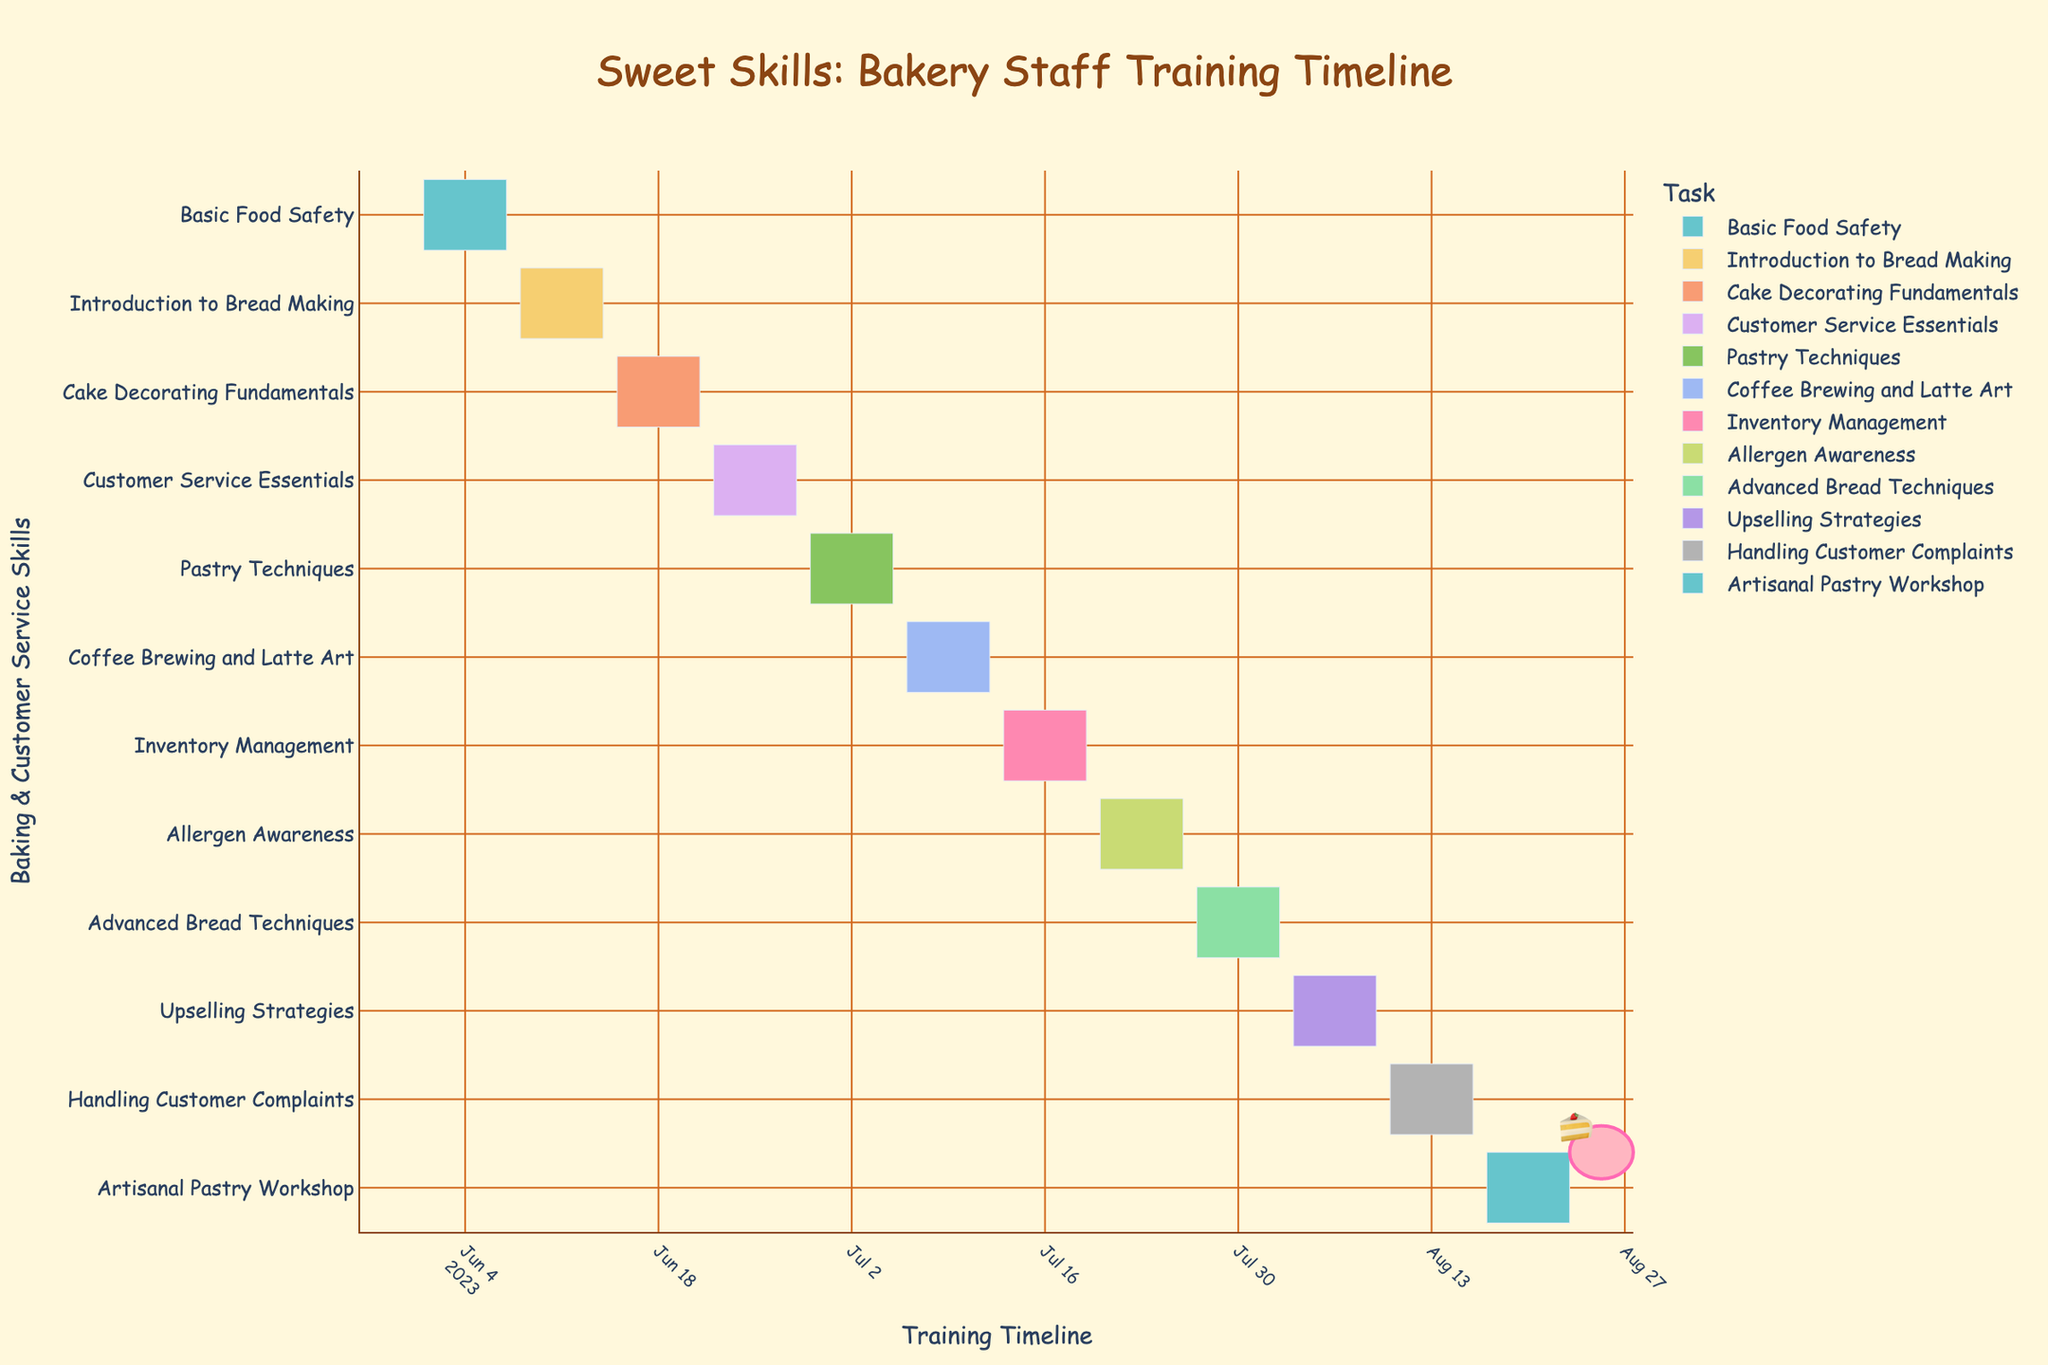Which task has the longest duration? By looking at the Gantt chart, notice the length of each bar. The longest bar corresponds to the “Basic Food Safety” task, which lasts for 7 days.
Answer: Basic Food Safety What dates cover the "Pastry Techniques" training? Find the "Pastry Techniques" bar on the Gantt chart and note its start and end dates. It starts on June 29, 2023, and ends on July 5, 2023.
Answer: June 29, 2023 to July 5, 2023 How many tasks are scheduled in July? Count the number of bars that fall within the July timeframe. There are tasks from July 1 to July 31. These tasks are: "Pastry Techniques", "Coffee Brewing and Latte Art", "Inventory Management", "Allergen Awareness", and "Advanced Bread Techniques".
Answer: 5 Which training takes place right after "Cake Decorating Fundamentals"? Find the end date of "Cake Decorating Fundamentals," which is June 21, 2023, and then identify the task that starts immediately after it. The next task is "Customer Service Essentials," which begins on June 22, 2023.
Answer: Customer Service Essentials Are there any tasks that last only one week (7 days)? Check the duration of each bar by subtracting the start date from the end date for each. Both "Basic Food Safety" (June 1-7) and "Introduction to Bread Making" (June 8-14) last for exactly 7 days.
Answer: Yes Which task runs from late July to early August? Look for a task bar that spans the transition from July to August. The "Advanced Bread Techniques" training runs from July 27, 2023, to August 2, 2023.
Answer: Advanced Bread Techniques What is the title of the Gantt chart? Simply read the title at the top of the Gantt chart. The title is "Sweet Skills: Bakery Staff Training Timeline".
Answer: Sweet Skills: Bakery Staff Training Timeline Which task comes last in the timeline? Identify the final bar on the Gantt chart, which represents the last task scheduled. The last task is "Artisanal Pastry Workshop," ending on August 23, 2023.
Answer: Artisanal Pastry Workshop How many tasks include dates in August? Look at the bars on the chart that extend into August. The tasks are "Advanced Bread Techniques," "Upselling Strategies," "Handling Customer Complaints," and "Artisanal Pastry Workshop".
Answer: 4 Which tasks are related to "Customer Service"? Identify tasks with titles indicating customer service skills. These tasks are "Customer Service Essentials", "Upselling Strategies", and "Handling Customer Complaints."
Answer: Customer Service Essentials, Upselling Strategies, Handling Customer Complaints 